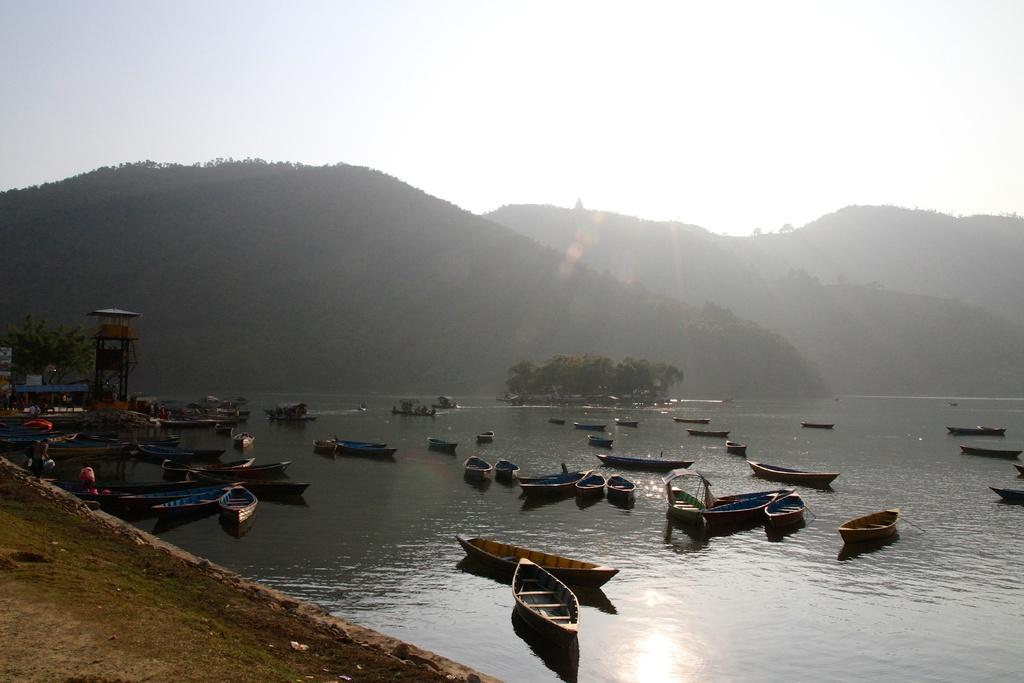What type of terrain is visible in the image? There is ground visible in the image. What natural feature is also visible in the image? There is water visible in the image. What type of vegetation can be seen in the image? There are trees in the image. What man-made objects are on the water in the image? There are boats on the surface of the water. What structures can be seen in the background of the image? There is a tower and mountains in the background of the image. What else is visible in the background of the image? The sky is visible in the background of the image. What color is the bead on the wrist of the person in the image? There is no person or bead present in the image. What type of sweater is the person wearing in the image? There is no person or sweater present in the image. 